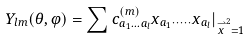Convert formula to latex. <formula><loc_0><loc_0><loc_500><loc_500>Y _ { l m } ( \theta , \varphi ) = \sum c _ { a _ { 1 } \dots a _ { l } } ^ { ( m ) } x _ { a _ { 1 } \cdot \dots \cdot } x _ { a _ { l } } | _ { \stackrel { \rightharpoonup } { x } ^ { 2 } = 1 }</formula> 